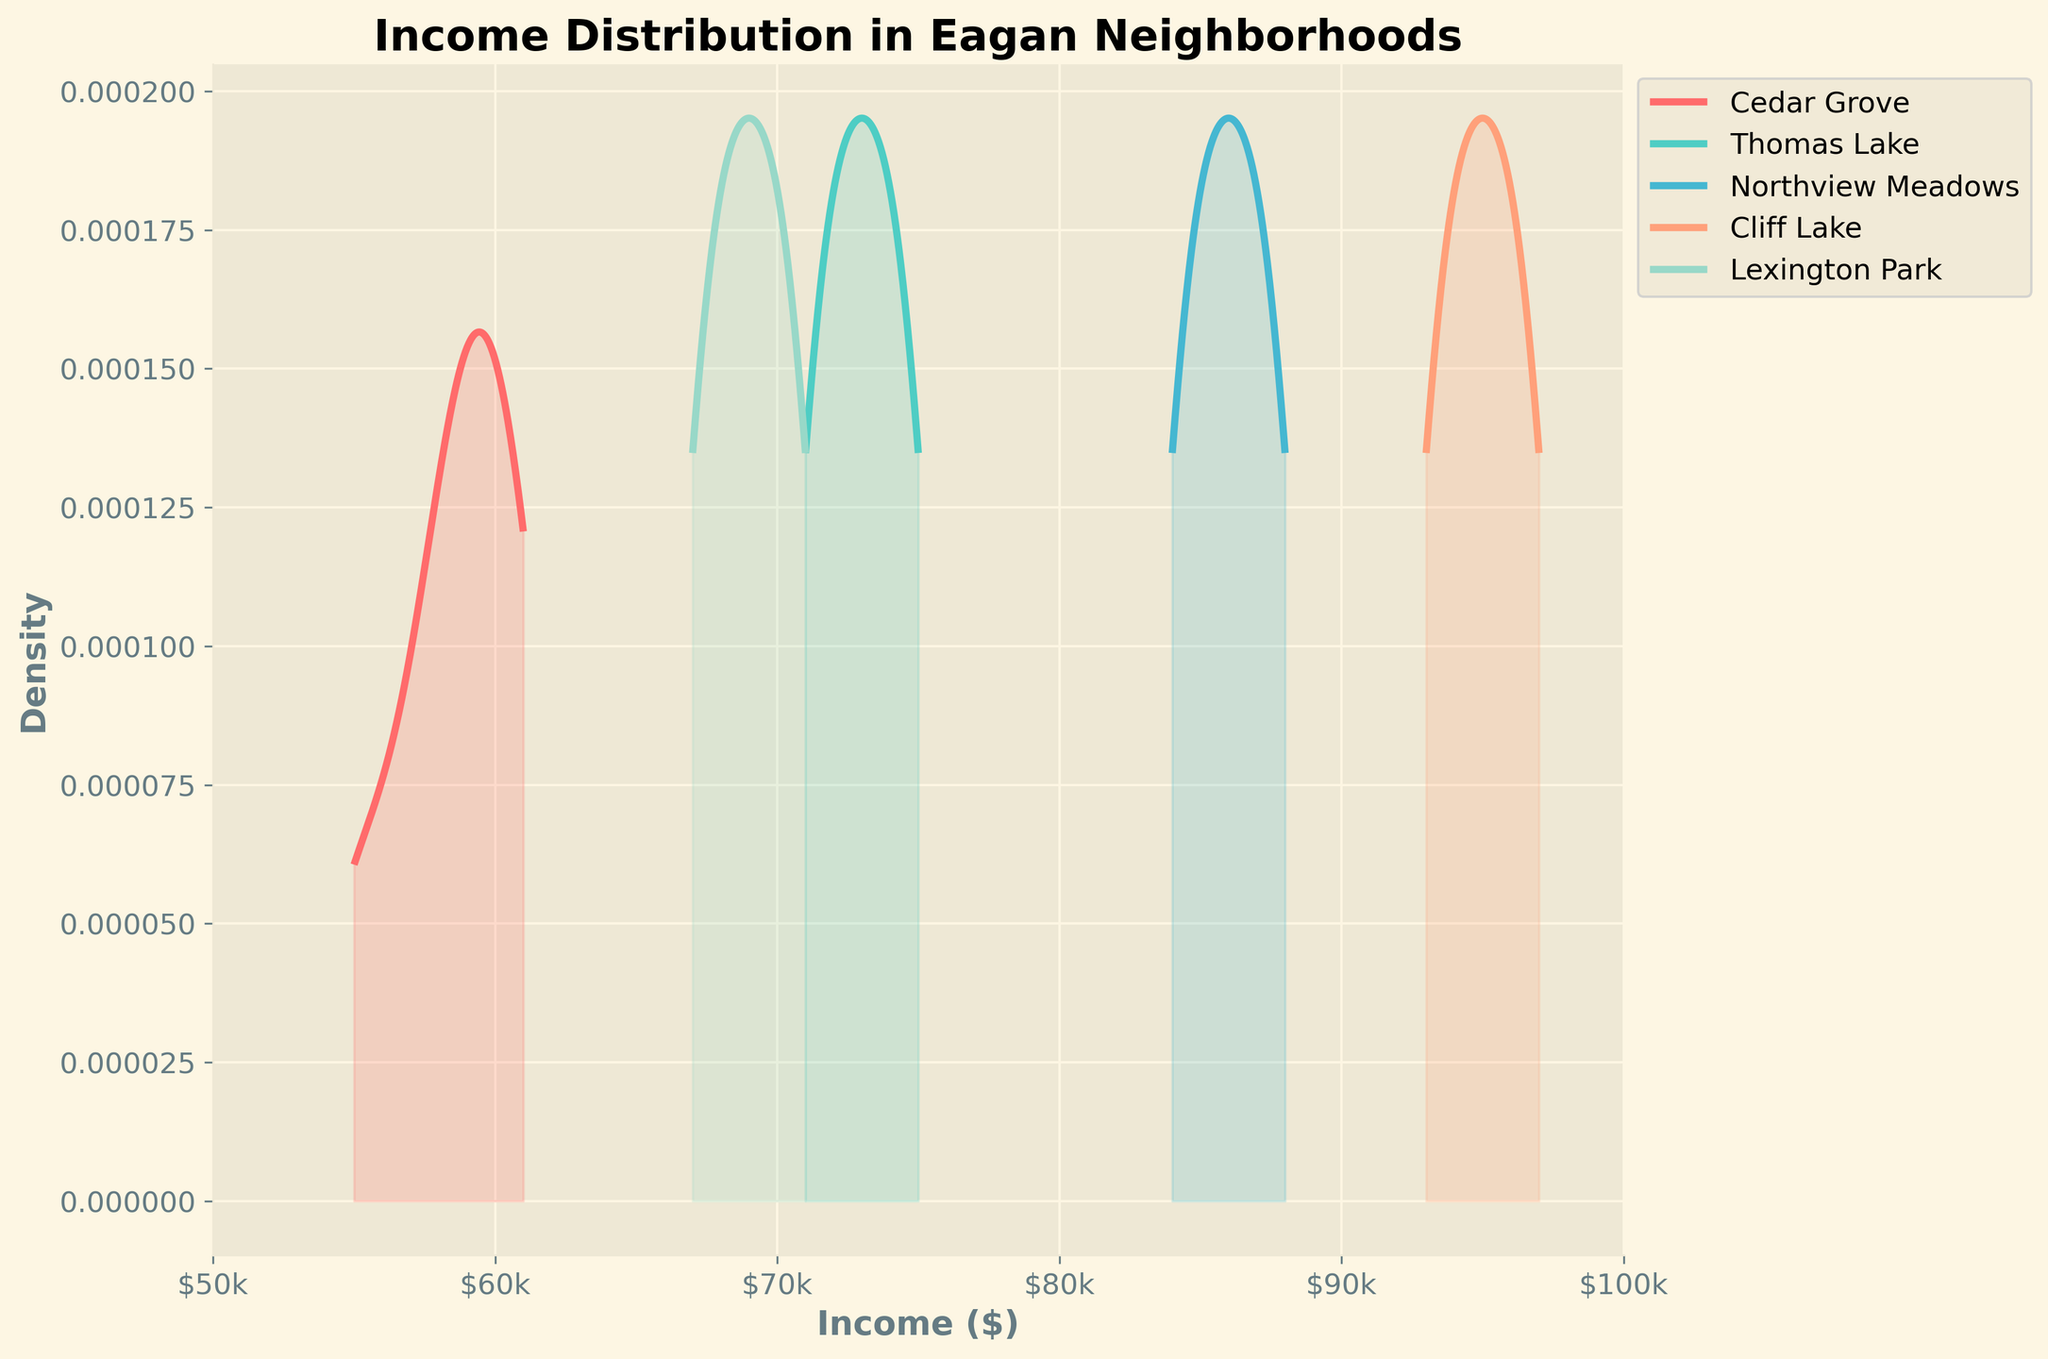How many different neighborhoods are represented in the figure? To determine the number of neighborhoods, refer to the legend in the plot, which lists all unique neighborhoods.
Answer: 5 Which neighborhood has the highest income density peak in the distribution? Look at the graph and find the neighborhood with the highest peak on the y-axis. The curve with the highest peak represents this neighborhood.
Answer: Cliff Lake What is the lowest income range shown on the x-axis? Check the x-axis for the smallest value, which is the starting point of the range.
Answer: $50k Which neighborhood has the widest spread in income distribution? Compare the width of the density plots for each neighborhood. The neighborhood with the widest spread will have a plot that covers the largest range on the x-axis.
Answer: Cliff Lake What is the approximate income range for Lexington Park? Observe the width of the density curve for Lexington Park. Note the minimum and maximum values on the x-axis that the curve spans.
Answer: $67k - $71k Which neighborhood has the lowest average income? Estimate the average income by looking at the peak of the density curve where it's most centralized. The neighborhood with the peak at the lowest income value has the lowest average income.
Answer: Cedar Grove Is Thomas Lake’s income distribution more spread out or more concentrated compared to Cedar Grove? Compare the width of the density curves for Thomas Lake and Cedar Grove. If Thomas Lake’s curve covers a larger range of x-values, it is more spread out, otherwise, it’s more concentrated.
Answer: More concentrated Between Northview Meadows and Cliff Lake, which neighborhood indicates a higher overall income level? Look at the x-axis peaks for Northview Meadows and Cliff Lake. The neighborhood with peaks further to the right indicates higher income levels.
Answer: Cliff Lake What income range covers the densest part of the Cedar Grove distribution? Find the part of Cedar Grove's density plot that has the highest y-values and note the corresponding x-value range.
Answer: $55k - $61k 